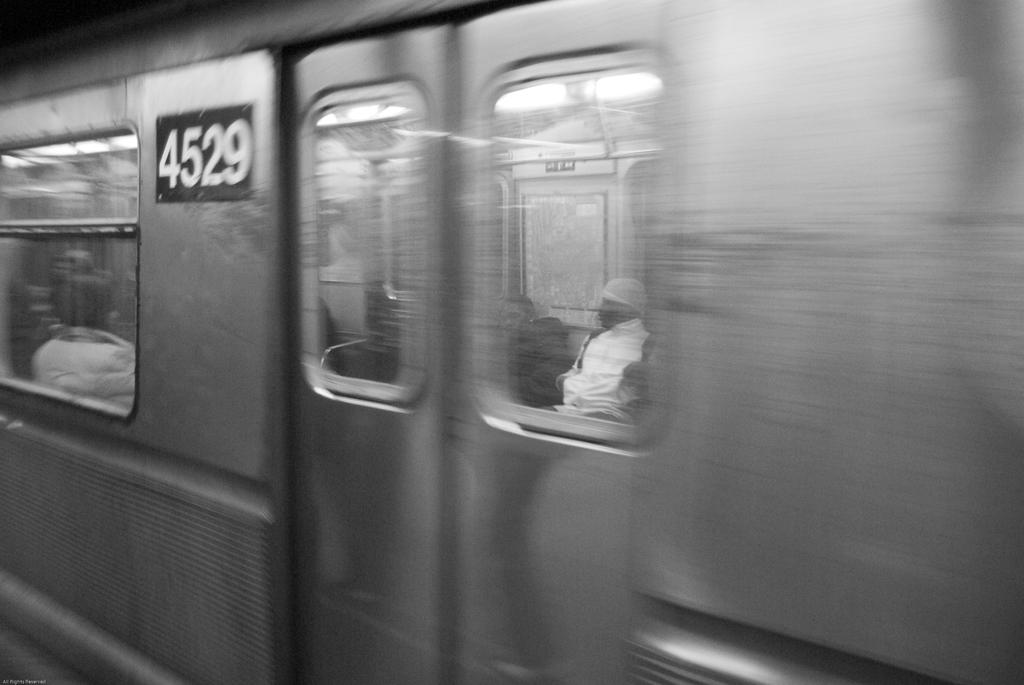<image>
Present a compact description of the photo's key features. Train with a 4529 that have people on it 